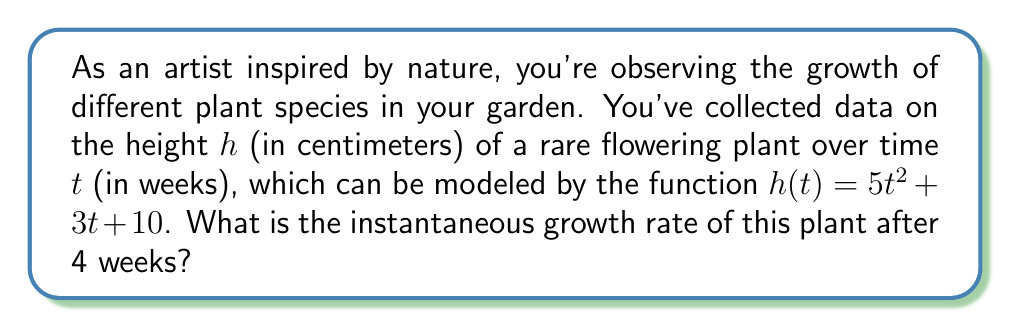Can you answer this question? To find the instantaneous growth rate after 4 weeks, we need to calculate the derivative of the height function $h(t)$ and then evaluate it at $t = 4$. Here's the step-by-step process:

1. Given function: $h(t) = 5t^2 + 3t + 10$

2. To find the derivative $h'(t)$, we use the power rule and constant rule:
   $h'(t) = \frac{d}{dt}(5t^2) + \frac{d}{dt}(3t) + \frac{d}{dt}(10)$
   $h'(t) = 10t + 3 + 0$
   $h'(t) = 10t + 3$

3. The derivative $h'(t)$ represents the instantaneous growth rate at any time $t$.

4. To find the growth rate after 4 weeks, we evaluate $h'(t)$ at $t = 4$:
   $h'(4) = 10(4) + 3$
   $h'(4) = 40 + 3 = 43$

Therefore, the instantaneous growth rate of the plant after 4 weeks is 43 cm/week.
Answer: 43 cm/week 